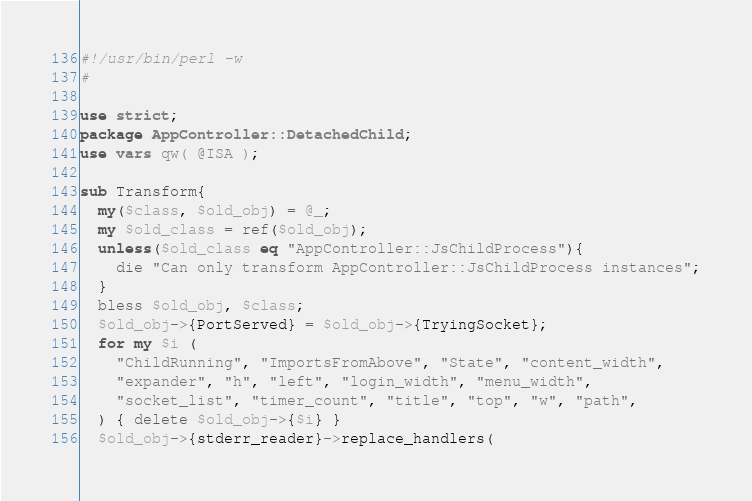Convert code to text. <code><loc_0><loc_0><loc_500><loc_500><_Perl_>#!/usr/bin/perl -w
#

use strict;
package AppController::DetachedChild;
use vars qw( @ISA );

sub Transform{
  my($class, $old_obj) = @_;
  my $old_class = ref($old_obj);
  unless($old_class eq "AppController::JsChildProcess"){
    die "Can only transform AppController::JsChildProcess instances";
  }
  bless $old_obj, $class;
  $old_obj->{PortServed} = $old_obj->{TryingSocket};
  for my $i (
    "ChildRunning", "ImportsFromAbove", "State", "content_width",
    "expander", "h", "left", "login_width", "menu_width", 
    "socket_list", "timer_count", "title", "top", "w", "path",
  ) { delete $old_obj->{$i} }
  $old_obj->{stderr_reader}->replace_handlers(</code> 